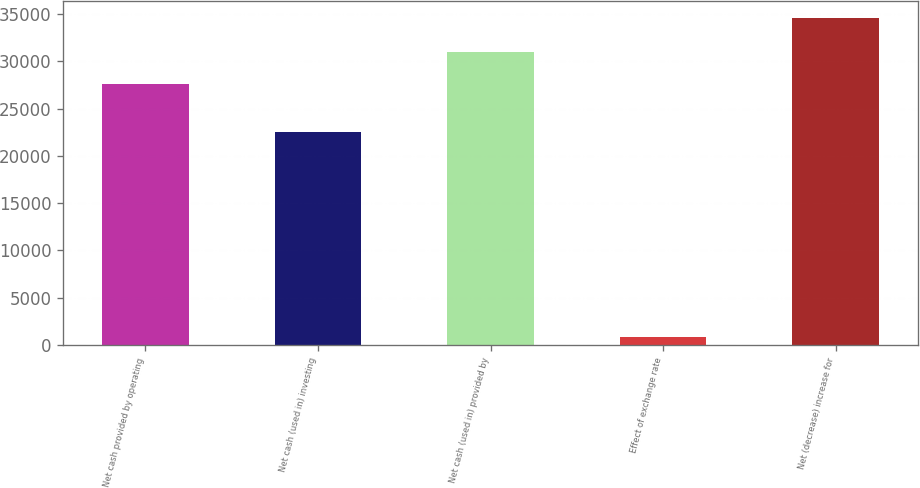Convert chart to OTSL. <chart><loc_0><loc_0><loc_500><loc_500><bar_chart><fcel>Net cash provided by operating<fcel>Net cash (used in) investing<fcel>Net cash (used in) provided by<fcel>Effect of exchange rate<fcel>Net (decrease) increase for<nl><fcel>27634<fcel>22499<fcel>31011.8<fcel>834<fcel>34612<nl></chart> 